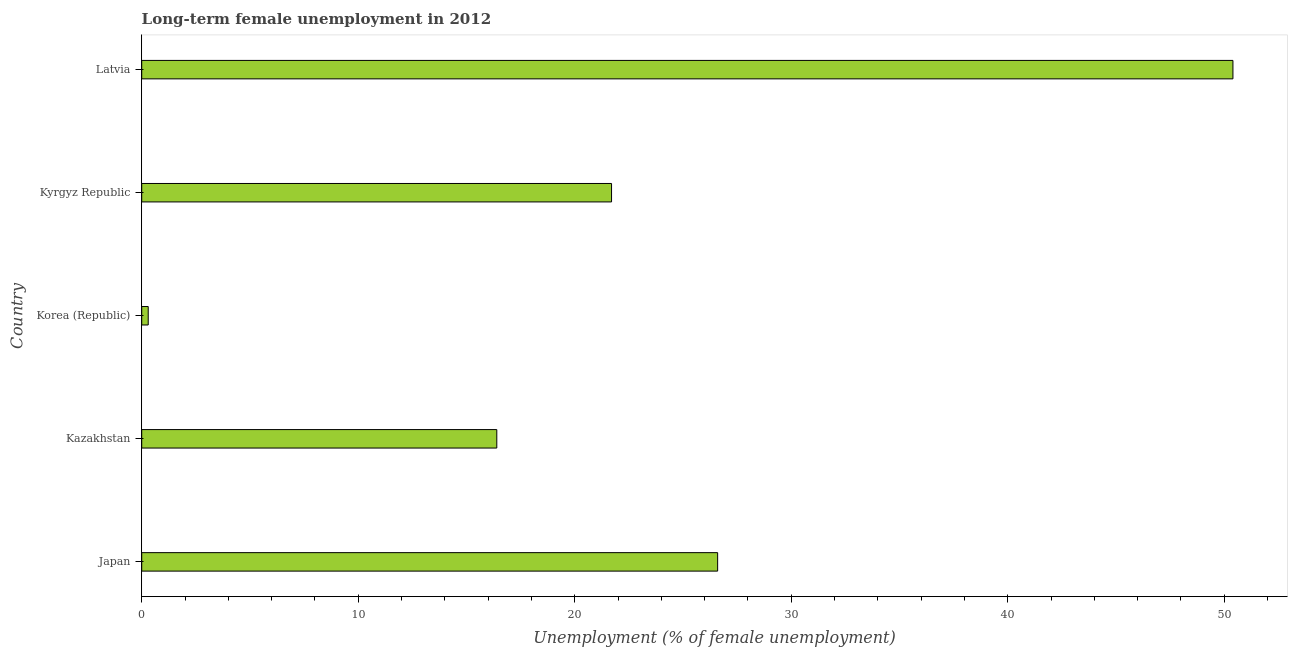What is the title of the graph?
Keep it short and to the point. Long-term female unemployment in 2012. What is the label or title of the X-axis?
Give a very brief answer. Unemployment (% of female unemployment). What is the long-term female unemployment in Korea (Republic)?
Offer a very short reply. 0.3. Across all countries, what is the maximum long-term female unemployment?
Your answer should be compact. 50.4. Across all countries, what is the minimum long-term female unemployment?
Your response must be concise. 0.3. In which country was the long-term female unemployment maximum?
Ensure brevity in your answer.  Latvia. What is the sum of the long-term female unemployment?
Give a very brief answer. 115.4. What is the difference between the long-term female unemployment in Korea (Republic) and Kyrgyz Republic?
Make the answer very short. -21.4. What is the average long-term female unemployment per country?
Your answer should be very brief. 23.08. What is the median long-term female unemployment?
Give a very brief answer. 21.7. What is the ratio of the long-term female unemployment in Kyrgyz Republic to that in Latvia?
Your answer should be very brief. 0.43. Is the difference between the long-term female unemployment in Kazakhstan and Korea (Republic) greater than the difference between any two countries?
Offer a terse response. No. What is the difference between the highest and the second highest long-term female unemployment?
Provide a short and direct response. 23.8. What is the difference between the highest and the lowest long-term female unemployment?
Your answer should be compact. 50.1. In how many countries, is the long-term female unemployment greater than the average long-term female unemployment taken over all countries?
Offer a very short reply. 2. Are the values on the major ticks of X-axis written in scientific E-notation?
Offer a very short reply. No. What is the Unemployment (% of female unemployment) in Japan?
Ensure brevity in your answer.  26.6. What is the Unemployment (% of female unemployment) in Kazakhstan?
Offer a terse response. 16.4. What is the Unemployment (% of female unemployment) in Korea (Republic)?
Your answer should be compact. 0.3. What is the Unemployment (% of female unemployment) in Kyrgyz Republic?
Ensure brevity in your answer.  21.7. What is the Unemployment (% of female unemployment) in Latvia?
Your response must be concise. 50.4. What is the difference between the Unemployment (% of female unemployment) in Japan and Kazakhstan?
Make the answer very short. 10.2. What is the difference between the Unemployment (% of female unemployment) in Japan and Korea (Republic)?
Ensure brevity in your answer.  26.3. What is the difference between the Unemployment (% of female unemployment) in Japan and Kyrgyz Republic?
Keep it short and to the point. 4.9. What is the difference between the Unemployment (% of female unemployment) in Japan and Latvia?
Your answer should be very brief. -23.8. What is the difference between the Unemployment (% of female unemployment) in Kazakhstan and Kyrgyz Republic?
Ensure brevity in your answer.  -5.3. What is the difference between the Unemployment (% of female unemployment) in Kazakhstan and Latvia?
Your answer should be very brief. -34. What is the difference between the Unemployment (% of female unemployment) in Korea (Republic) and Kyrgyz Republic?
Provide a succinct answer. -21.4. What is the difference between the Unemployment (% of female unemployment) in Korea (Republic) and Latvia?
Offer a very short reply. -50.1. What is the difference between the Unemployment (% of female unemployment) in Kyrgyz Republic and Latvia?
Your response must be concise. -28.7. What is the ratio of the Unemployment (% of female unemployment) in Japan to that in Kazakhstan?
Make the answer very short. 1.62. What is the ratio of the Unemployment (% of female unemployment) in Japan to that in Korea (Republic)?
Your answer should be compact. 88.67. What is the ratio of the Unemployment (% of female unemployment) in Japan to that in Kyrgyz Republic?
Provide a succinct answer. 1.23. What is the ratio of the Unemployment (% of female unemployment) in Japan to that in Latvia?
Your answer should be very brief. 0.53. What is the ratio of the Unemployment (% of female unemployment) in Kazakhstan to that in Korea (Republic)?
Offer a very short reply. 54.67. What is the ratio of the Unemployment (% of female unemployment) in Kazakhstan to that in Kyrgyz Republic?
Make the answer very short. 0.76. What is the ratio of the Unemployment (% of female unemployment) in Kazakhstan to that in Latvia?
Make the answer very short. 0.33. What is the ratio of the Unemployment (% of female unemployment) in Korea (Republic) to that in Kyrgyz Republic?
Offer a terse response. 0.01. What is the ratio of the Unemployment (% of female unemployment) in Korea (Republic) to that in Latvia?
Ensure brevity in your answer.  0.01. What is the ratio of the Unemployment (% of female unemployment) in Kyrgyz Republic to that in Latvia?
Ensure brevity in your answer.  0.43. 